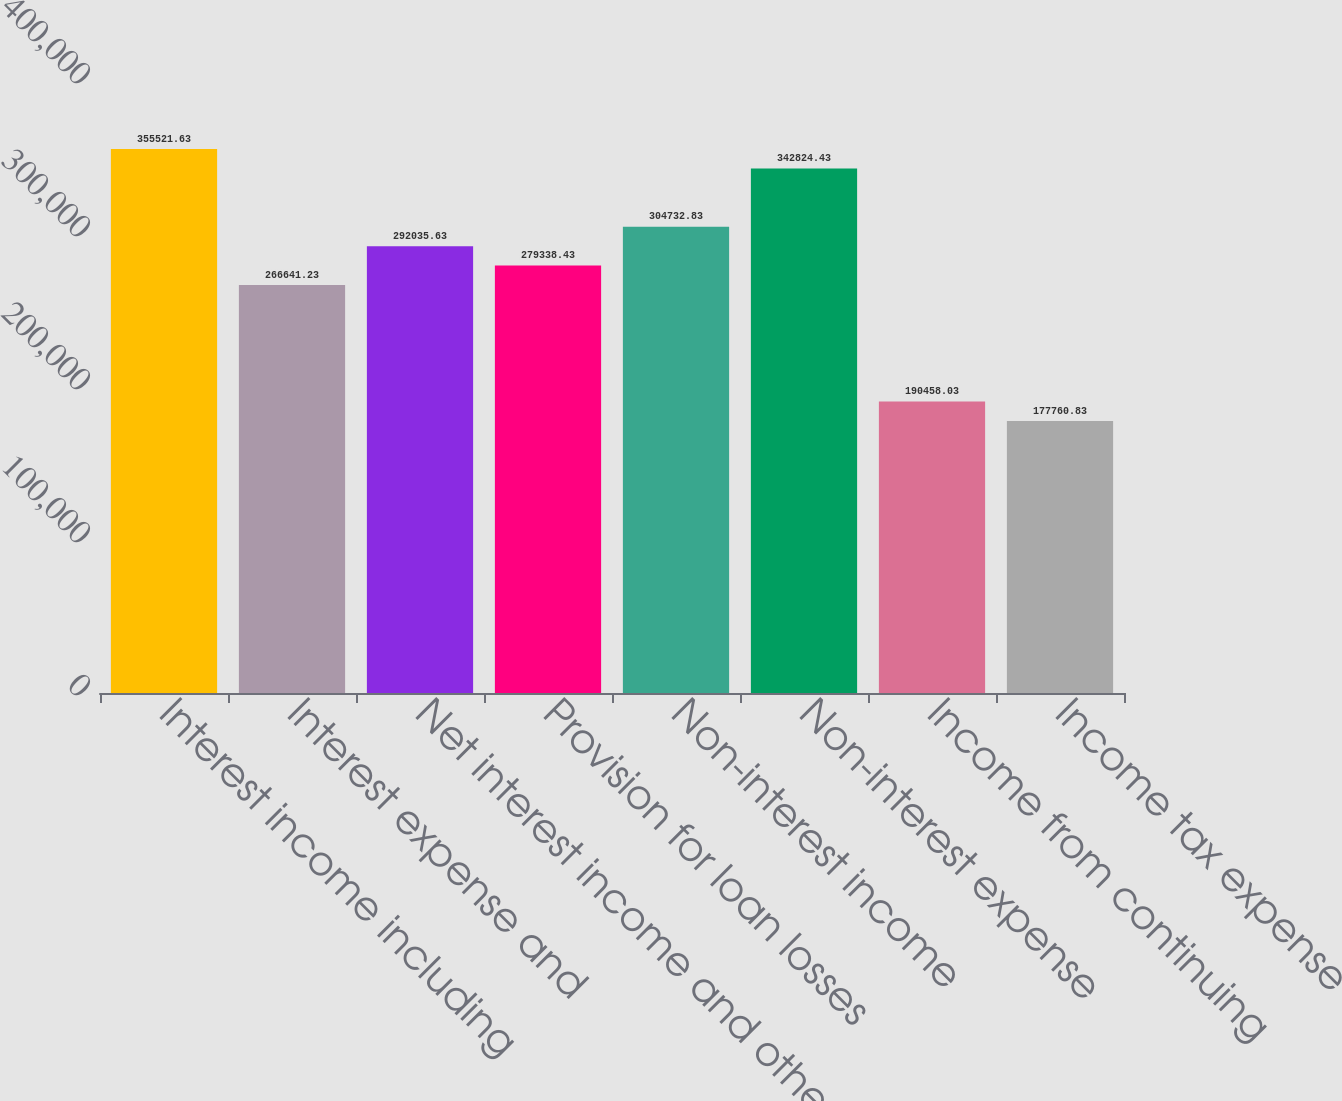Convert chart to OTSL. <chart><loc_0><loc_0><loc_500><loc_500><bar_chart><fcel>Interest income including<fcel>Interest expense and<fcel>Net interest income and other<fcel>Provision for loan losses<fcel>Non-interest income<fcel>Non-interest expense<fcel>Income from continuing<fcel>Income tax expense<nl><fcel>355522<fcel>266641<fcel>292036<fcel>279338<fcel>304733<fcel>342824<fcel>190458<fcel>177761<nl></chart> 